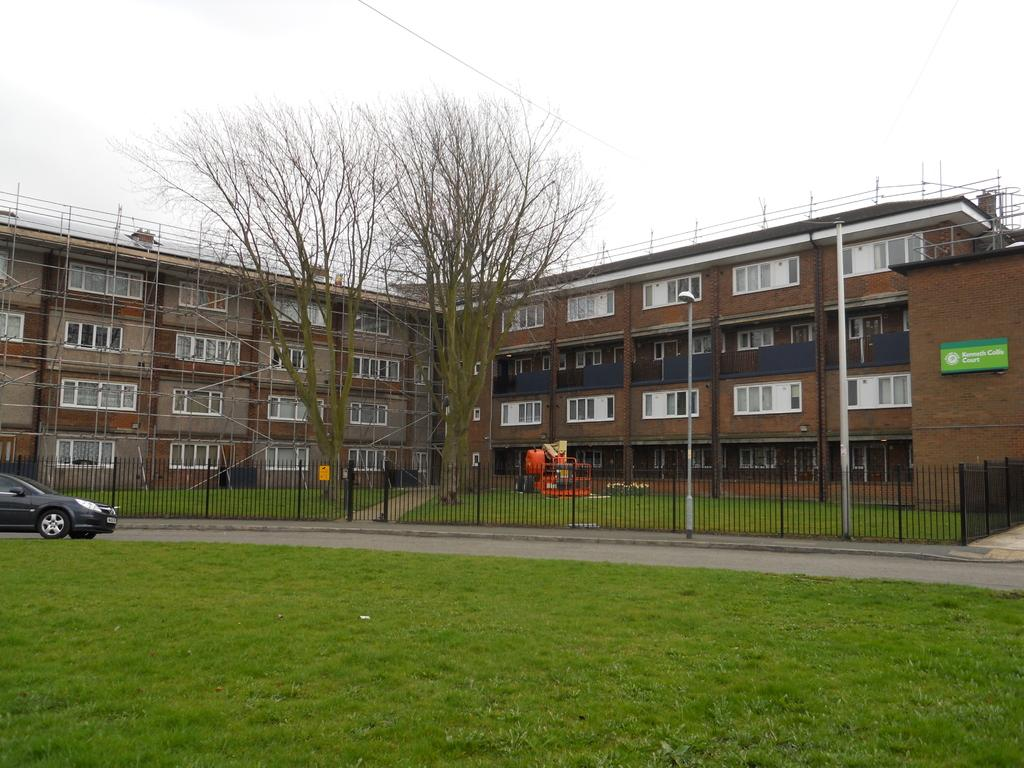What type of vegetation can be seen in the image? There is grass and trees in the image. What is on the road in the image? There is a car on the road in the image. What type of structure is present in the image? There is railing and a light pole in the image. What else is visible in the image? There is a vehicle and metal rods in front of a building in the image. What can be seen in the background of the image? The sky is visible in the background of the image. Where is the shelf located in the image? There is no shelf present in the image. Can you see any cactus in the image? There are no cactus in the image; it features grass and trees. What type of alarm is going off in the image? There is no alarm present in the image. 